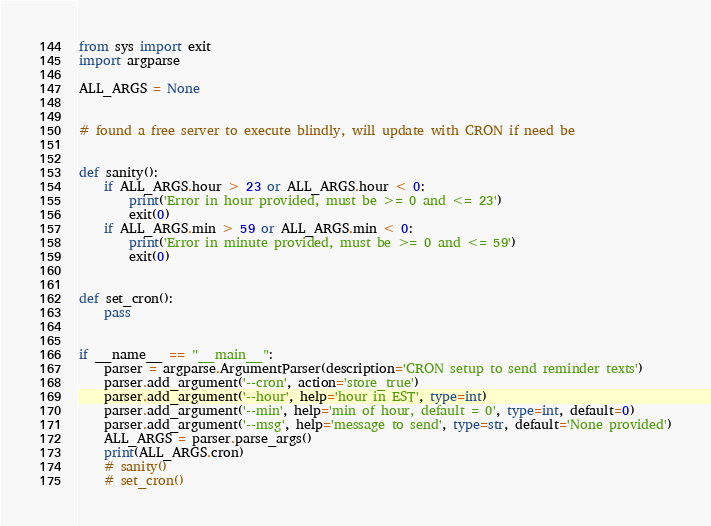<code> <loc_0><loc_0><loc_500><loc_500><_Python_>from sys import exit
import argparse

ALL_ARGS = None


# found a free server to execute blindly, will update with CRON if need be


def sanity():
    if ALL_ARGS.hour > 23 or ALL_ARGS.hour < 0:
        print('Error in hour provided, must be >= 0 and <= 23')
        exit(0)
    if ALL_ARGS.min > 59 or ALL_ARGS.min < 0:
        print('Error in minute provided, must be >= 0 and <= 59')
        exit(0)


def set_cron():
    pass


if __name__ == "__main__":
    parser = argparse.ArgumentParser(description='CRON setup to send reminder texts')
    parser.add_argument('--cron', action='store_true')
    parser.add_argument('--hour', help='hour in EST', type=int)
    parser.add_argument('--min', help='min of hour, default = 0', type=int, default=0)
    parser.add_argument('--msg', help='message to send', type=str, default='None provided')
    ALL_ARGS = parser.parse_args()
    print(ALL_ARGS.cron)
    # sanity()
    # set_cron()
</code> 